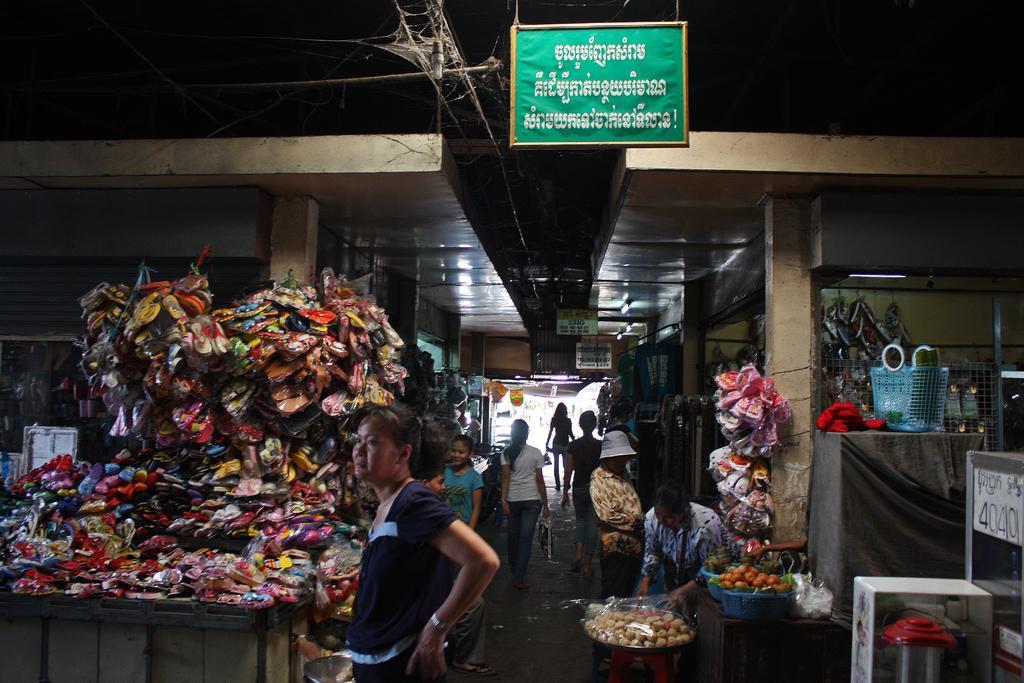Please provide a concise description of this image. In this image we can see a few people, some of them are holding bags, there are some fruits, food items, foot wears on a table, also we can see shutters, rooftops, lights, and board with some text written on it. 